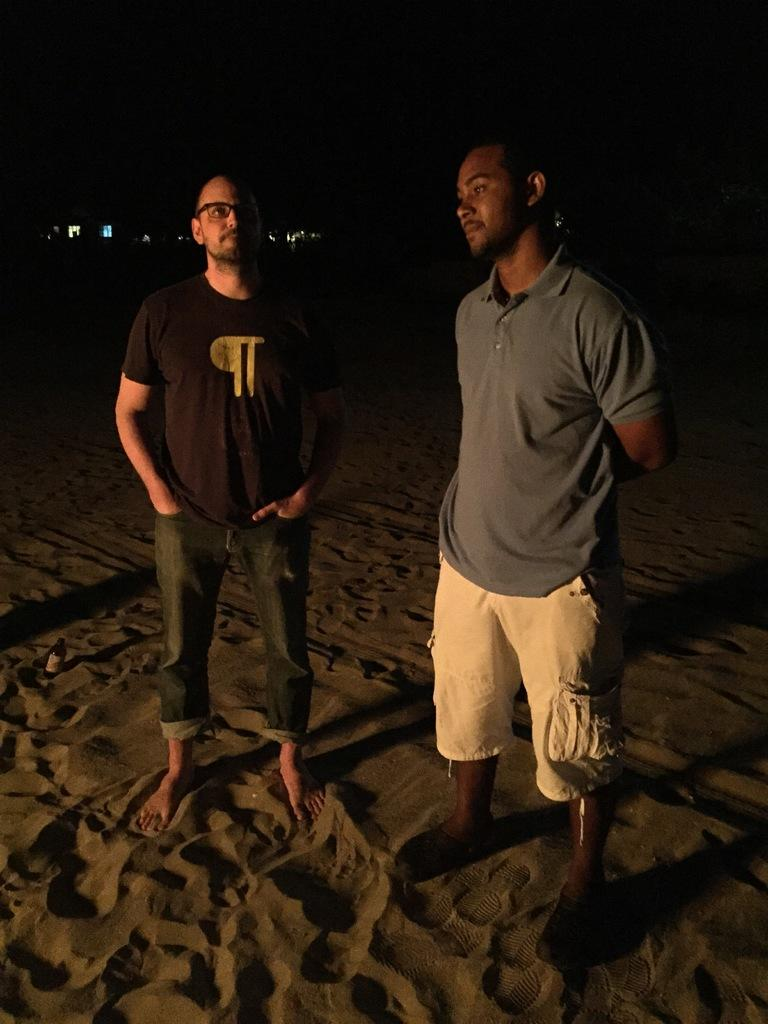How many people are in the image? There are two persons in the image. What is the surface they are standing on? The two persons are standing on the sand. Can you describe one of the persons in the image? One of the persons is wearing spectacles. What is the color of the background in the image? The background of the image is dark. What type of company does the fireman work for in the image? There is no fireman present in the image, so it is not possible to determine the company they might work for. Can you tell me about the flight that is taking place in the image? There is no flight or reference to aviation in the image. 